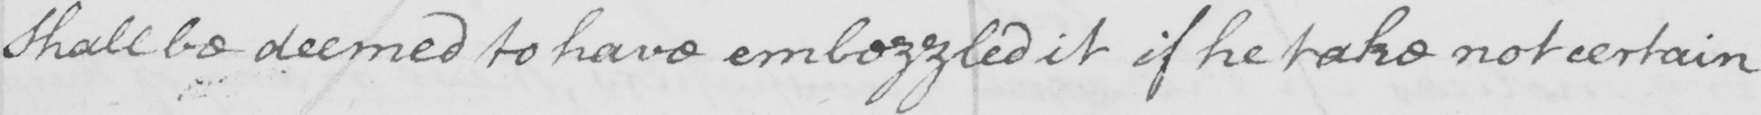Please provide the text content of this handwritten line. shall be deemed to have embezzled it if he take not certain 